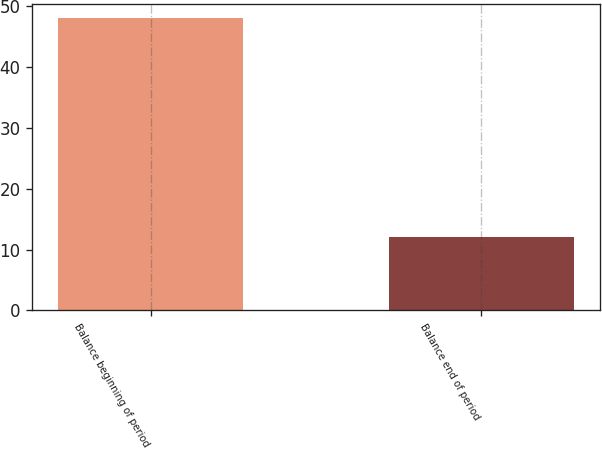Convert chart to OTSL. <chart><loc_0><loc_0><loc_500><loc_500><bar_chart><fcel>Balance beginning of period<fcel>Balance end of period<nl><fcel>48<fcel>12<nl></chart> 